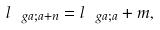<formula> <loc_0><loc_0><loc_500><loc_500>l _ { \ g a ; a + n } = l _ { \ g a ; a } + m ,</formula> 